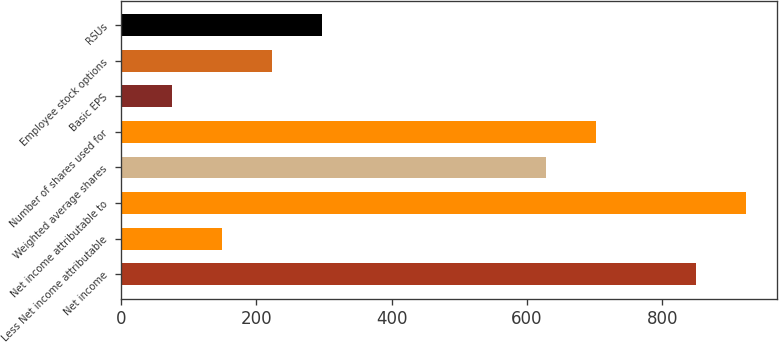<chart> <loc_0><loc_0><loc_500><loc_500><bar_chart><fcel>Net income<fcel>Less Net income attributable<fcel>Net income attributable to<fcel>Weighted average shares<fcel>Number of shares used for<fcel>Basic EPS<fcel>Employee stock options<fcel>RSUs<nl><fcel>849.48<fcel>149.03<fcel>923.35<fcel>627.87<fcel>701.74<fcel>75.16<fcel>222.9<fcel>296.77<nl></chart> 